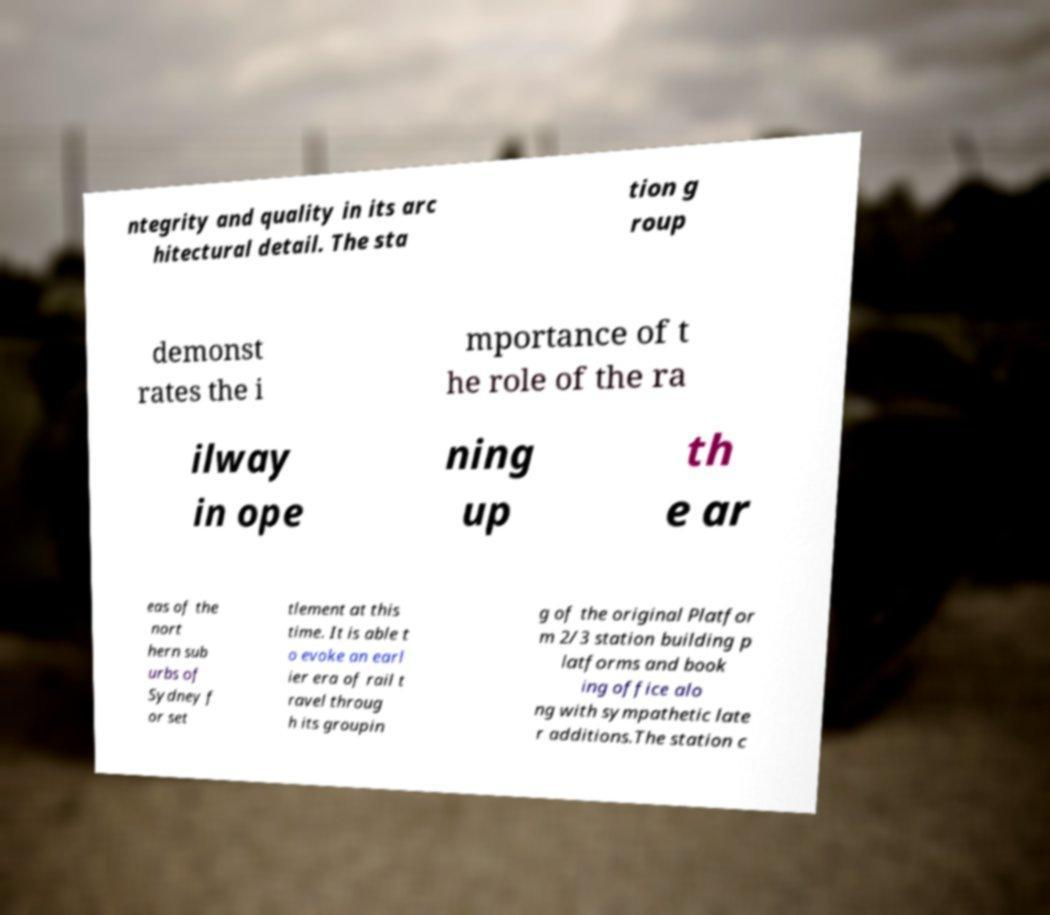Could you extract and type out the text from this image? ntegrity and quality in its arc hitectural detail. The sta tion g roup demonst rates the i mportance of t he role of the ra ilway in ope ning up th e ar eas of the nort hern sub urbs of Sydney f or set tlement at this time. It is able t o evoke an earl ier era of rail t ravel throug h its groupin g of the original Platfor m 2/3 station building p latforms and book ing office alo ng with sympathetic late r additions.The station c 